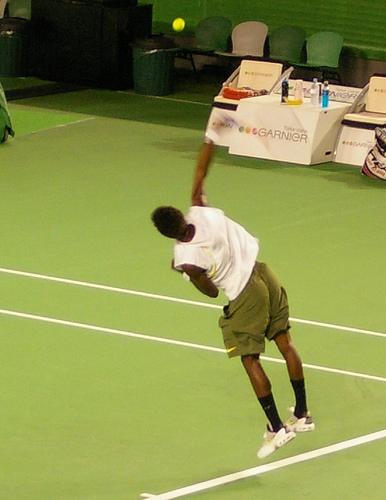What color are the mans socks?
Concise answer only. Black. What is this person holding?
Quick response, please. Racket. Is the man professional?
Keep it brief. Yes. Is the man in motion?
Quick response, please. Yes. What color are the man's shorts?
Give a very brief answer. Green. 